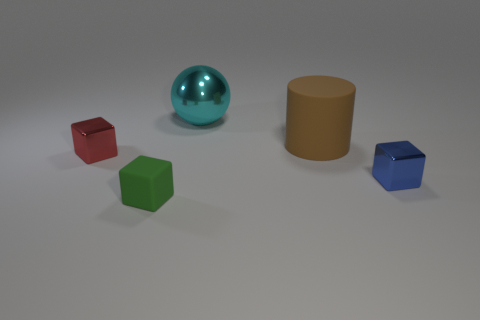Are there an equal number of small metallic cubes on the left side of the tiny red object and big blue spheres?
Ensure brevity in your answer.  Yes. There is a metal block on the left side of the shiny cube in front of the tiny red metallic cube; how many small blue metallic objects are to the right of it?
Provide a short and direct response. 1. Is the size of the red cube the same as the rubber thing to the right of the tiny green matte block?
Offer a terse response. No. What number of blue things are there?
Provide a succinct answer. 1. There is a rubber object in front of the small red object; does it have the same size as the cube on the right side of the cyan shiny ball?
Provide a succinct answer. Yes. What color is the small rubber object that is the same shape as the small red metallic object?
Offer a terse response. Green. Do the big brown object and the big metallic thing have the same shape?
Ensure brevity in your answer.  No. How many small green things have the same material as the small green cube?
Give a very brief answer. 0. How many things are either tiny brown matte cylinders or red cubes?
Provide a succinct answer. 1. Is there a small thing that is to the right of the metal block that is to the left of the big rubber object?
Offer a very short reply. Yes. 